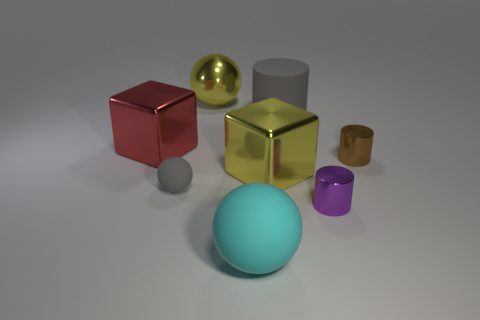How many other objects are the same size as the gray rubber sphere?
Offer a terse response. 2. The matte cylinder has what color?
Keep it short and to the point. Gray. What number of rubber things are cubes or gray balls?
Offer a terse response. 1. What size is the yellow metallic thing that is in front of the cylinder behind the object to the left of the small rubber sphere?
Provide a short and direct response. Large. How big is the metallic thing that is on the left side of the brown metal object and on the right side of the rubber cylinder?
Give a very brief answer. Small. There is a large sphere behind the tiny gray matte thing; is it the same color as the matte ball behind the large cyan ball?
Your answer should be compact. No. There is a tiny brown cylinder; how many yellow shiny objects are behind it?
Provide a succinct answer. 1. There is a metal object that is in front of the rubber ball to the left of the yellow shiny ball; is there a small brown metal thing that is in front of it?
Give a very brief answer. No. What number of purple metal cylinders have the same size as the gray ball?
Offer a terse response. 1. There is a ball in front of the small metal object to the left of the small brown cylinder; what is its material?
Provide a succinct answer. Rubber. 